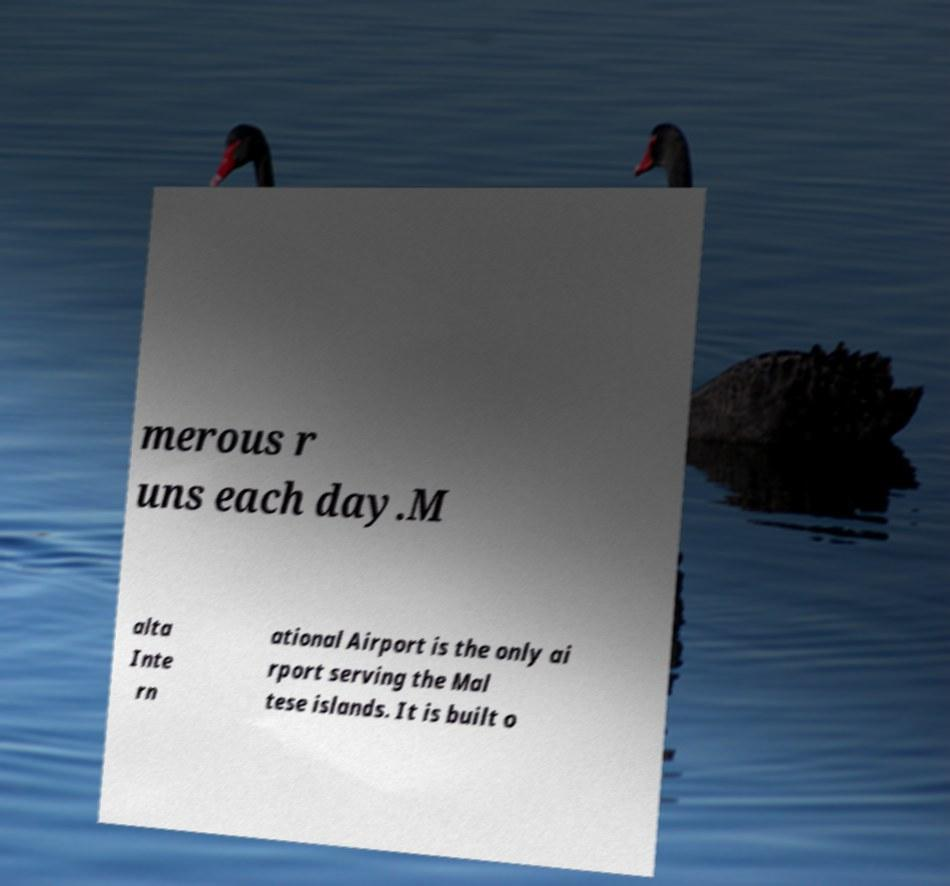Could you assist in decoding the text presented in this image and type it out clearly? merous r uns each day.M alta Inte rn ational Airport is the only ai rport serving the Mal tese islands. It is built o 